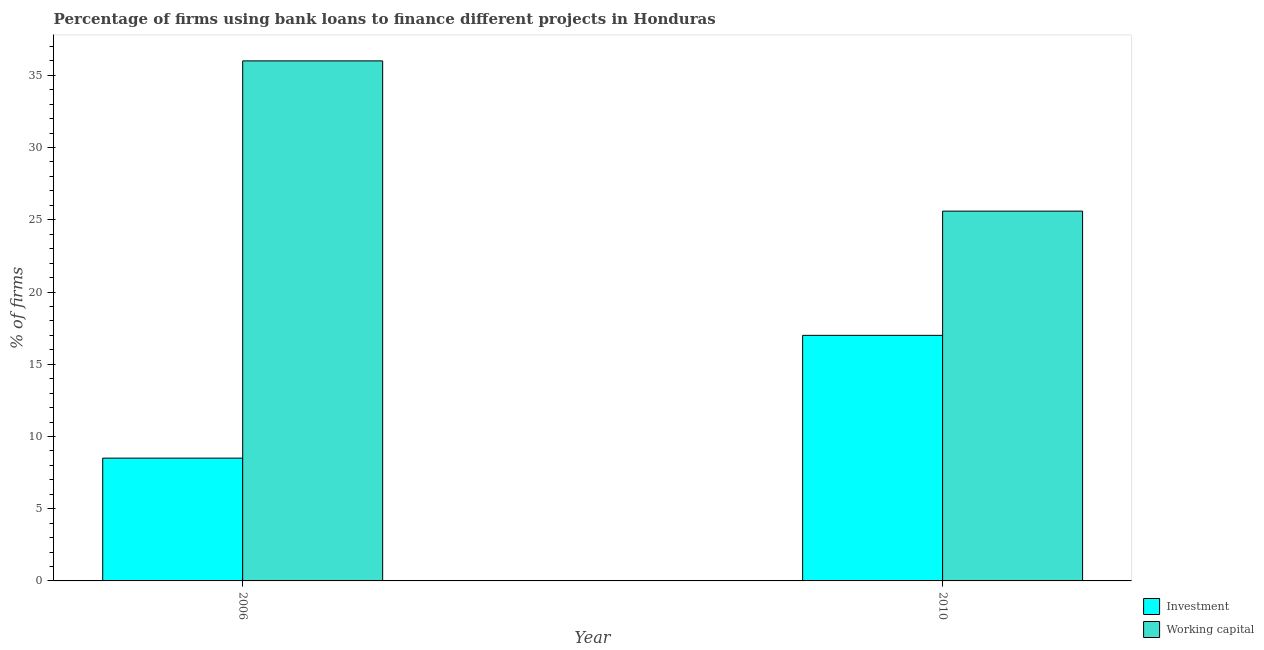How many different coloured bars are there?
Ensure brevity in your answer.  2. How many groups of bars are there?
Provide a short and direct response. 2. Are the number of bars on each tick of the X-axis equal?
Give a very brief answer. Yes. How many bars are there on the 2nd tick from the left?
Your answer should be very brief. 2. How many bars are there on the 2nd tick from the right?
Keep it short and to the point. 2. What is the label of the 1st group of bars from the left?
Ensure brevity in your answer.  2006. In how many cases, is the number of bars for a given year not equal to the number of legend labels?
Provide a short and direct response. 0. What is the percentage of firms using banks to finance working capital in 2010?
Give a very brief answer. 25.6. Across all years, what is the maximum percentage of firms using banks to finance working capital?
Your answer should be compact. 36. Across all years, what is the minimum percentage of firms using banks to finance investment?
Your answer should be compact. 8.5. In which year was the percentage of firms using banks to finance investment maximum?
Keep it short and to the point. 2010. In which year was the percentage of firms using banks to finance investment minimum?
Ensure brevity in your answer.  2006. What is the total percentage of firms using banks to finance working capital in the graph?
Your answer should be compact. 61.6. What is the difference between the percentage of firms using banks to finance working capital in 2010 and the percentage of firms using banks to finance investment in 2006?
Give a very brief answer. -10.4. What is the average percentage of firms using banks to finance working capital per year?
Ensure brevity in your answer.  30.8. What does the 2nd bar from the left in 2006 represents?
Offer a terse response. Working capital. What does the 2nd bar from the right in 2006 represents?
Keep it short and to the point. Investment. How many bars are there?
Give a very brief answer. 4. How many years are there in the graph?
Offer a very short reply. 2. What is the difference between two consecutive major ticks on the Y-axis?
Offer a terse response. 5. Does the graph contain any zero values?
Provide a short and direct response. No. Does the graph contain grids?
Ensure brevity in your answer.  No. What is the title of the graph?
Give a very brief answer. Percentage of firms using bank loans to finance different projects in Honduras. What is the label or title of the Y-axis?
Offer a terse response. % of firms. What is the % of firms in Working capital in 2006?
Give a very brief answer. 36. What is the % of firms of Investment in 2010?
Offer a terse response. 17. What is the % of firms in Working capital in 2010?
Your answer should be compact. 25.6. Across all years, what is the maximum % of firms in Working capital?
Provide a succinct answer. 36. Across all years, what is the minimum % of firms in Investment?
Ensure brevity in your answer.  8.5. Across all years, what is the minimum % of firms of Working capital?
Provide a short and direct response. 25.6. What is the total % of firms of Working capital in the graph?
Offer a very short reply. 61.6. What is the difference between the % of firms in Investment in 2006 and that in 2010?
Your answer should be compact. -8.5. What is the difference between the % of firms of Working capital in 2006 and that in 2010?
Offer a terse response. 10.4. What is the difference between the % of firms of Investment in 2006 and the % of firms of Working capital in 2010?
Ensure brevity in your answer.  -17.1. What is the average % of firms of Investment per year?
Your answer should be compact. 12.75. What is the average % of firms in Working capital per year?
Give a very brief answer. 30.8. In the year 2006, what is the difference between the % of firms of Investment and % of firms of Working capital?
Make the answer very short. -27.5. What is the ratio of the % of firms of Investment in 2006 to that in 2010?
Provide a succinct answer. 0.5. What is the ratio of the % of firms of Working capital in 2006 to that in 2010?
Offer a terse response. 1.41. What is the difference between the highest and the second highest % of firms in Working capital?
Your answer should be compact. 10.4. What is the difference between the highest and the lowest % of firms of Working capital?
Provide a short and direct response. 10.4. 